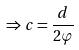<formula> <loc_0><loc_0><loc_500><loc_500>\Rightarrow c = \frac { d } { 2 \varphi }</formula> 